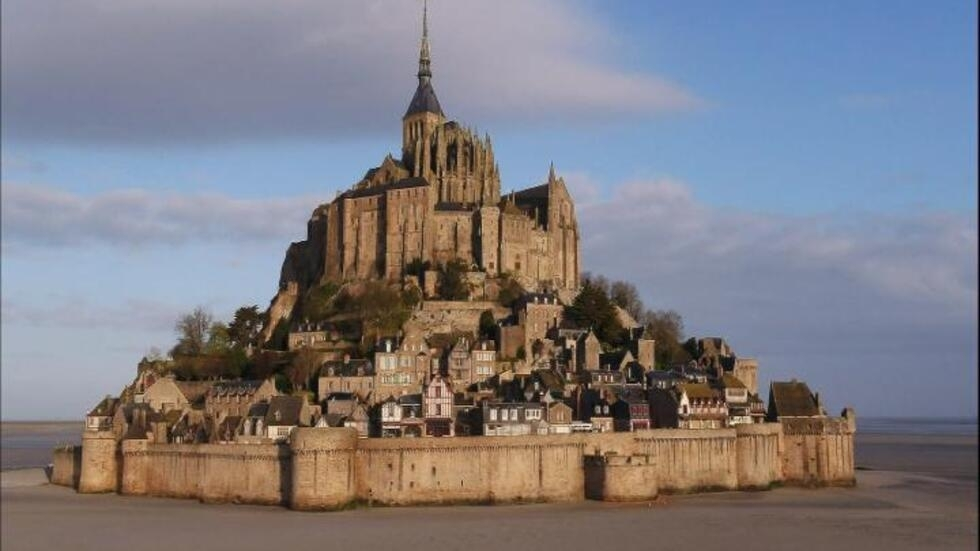Why do people visit this place? What can they experience here? Visitors are drawn to Mont Saint Michel for its breathtaking architecture, historical significance, and unique landscape. Walking through its narrow cobblestone streets, tourists can experience a journey back in time, exploring ancient buildings, quaint shops, and vibrant cafes. The abbey itself offers stunning views and a deep dive into monastic life during the medieval period. Additionally, the dynamic tides surrounding the island add a natural wonder to the visit, making every trip a unique experience. 